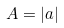<formula> <loc_0><loc_0><loc_500><loc_500>A = | a |</formula> 